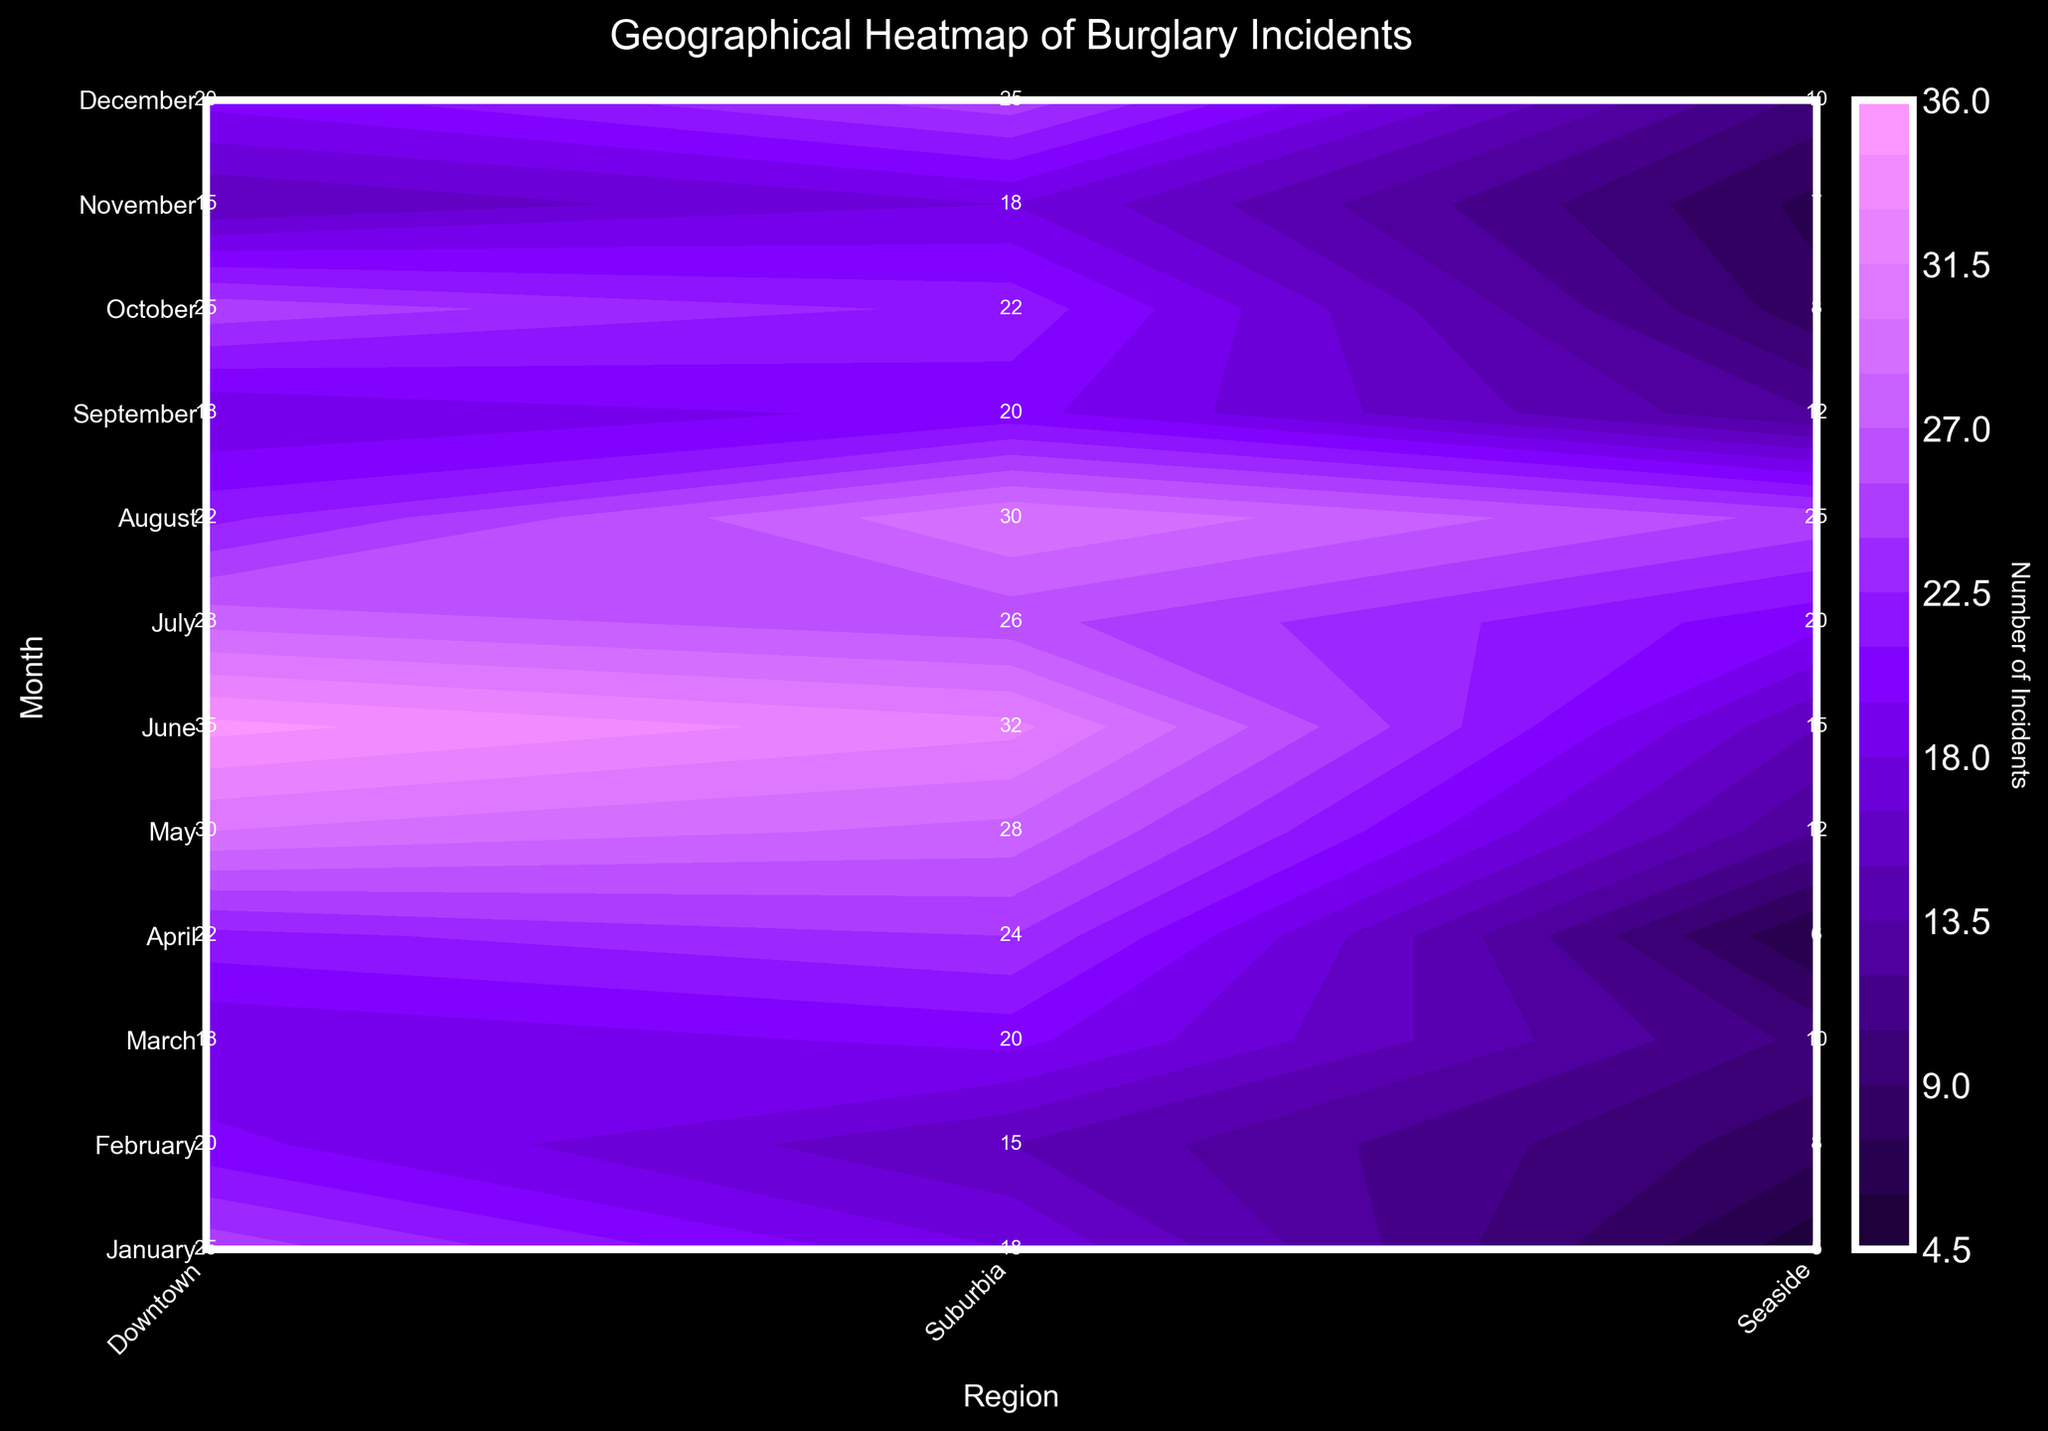What's the title of the figure? The title of the figure appears at the top center and is designed to summarize the main point of the plot.
Answer: Geographical Heatmap of Burglary Incidents What are the regions listed on the x-axis? The x-axis labels are rotated for better readability and represent different areas where incidents are recorded.
Answer: Downtown, Suburbia, Seaside During which month does "Suburbia" have the highest number of incidents? Look at the contour plot and identify the peak value along the month corresponding to "Suburbia".
Answer: June How many burglary incidents were there in "Seaside" in August? Locate August on the y-axis, then trace horizontally to the "Seaside" region on the x-axis. The number is annotated on the plot.
Answer: 25 In which month does "Downtown" have the lowest number of incidents? Compare the incident numbers for "Downtown" across all months, looking for the smallest value shown.
Answer: November Which month has the highest overall number of burglary incidents in all regions combined? Sum the incidents for each month across all regions. Identify the month with the highest total.
Answer: June Compare the incidents in "Suburbia" for January and December. Which month has more and by how much? Find the incident numbers for "Suburbia" in January and December and calculate the difference.
Answer: December by 7 Is there a general trend in the number of incidents for "Downtown" from January to December? Observe the incident numbers for "Downtown" month by month to determine if there's an increasing, decreasing or no clear trend.
Answer: No clear trend During which months did "Seaside" experience more than 15 incidents? Identify the months where the annotated numbers for "Seaside" are greater than 15.
Answer: June, July, August Which region generally experiences the most burglary incidents? Compare the incident numbers across all months for each region and determine which has consistently higher numbers.
Answer: Downtown 